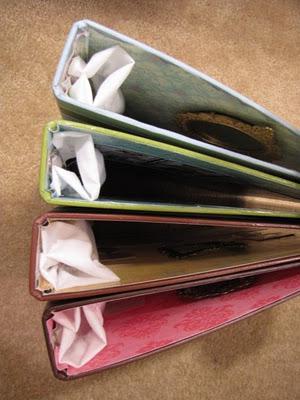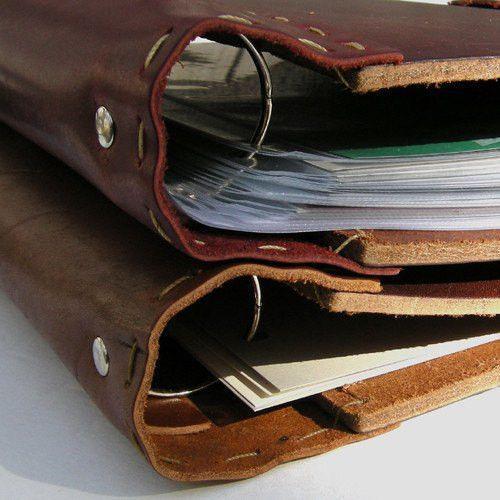The first image is the image on the left, the second image is the image on the right. For the images shown, is this caption "Each image contains a single brown binder" true? Answer yes or no. No. 